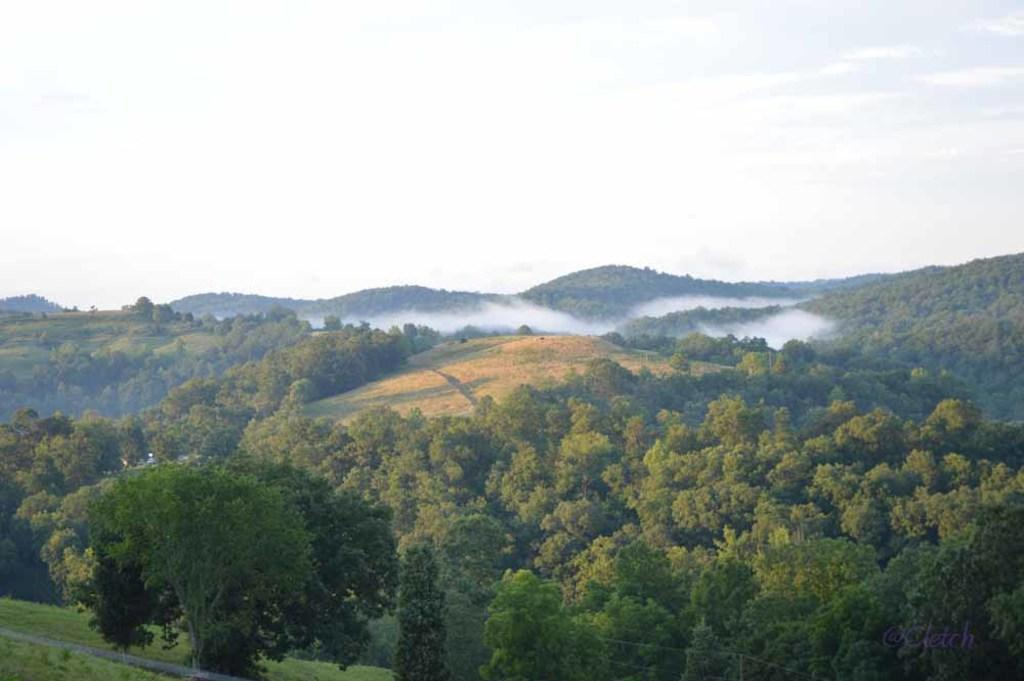What type of natural formation can be seen in the image? There is a group of trees in the image. What other geographical features are visible in the image? There are hills visible in the image. What man-made object can be seen in the image? There is a pole with wires in the image. What part of the natural environment is visible in the image? The sky is visible in the image. How would you describe the weather based on the appearance of the sky? The sky appears to be cloudy in the image. What type of veil is draped over the trees in the image? There is no veil present in the image; it features a group of trees, hills, a pole with wires, and a cloudy sky. Can you tell me how many brothers are visible in the image? There are no people, let alone brothers, present in the image. 